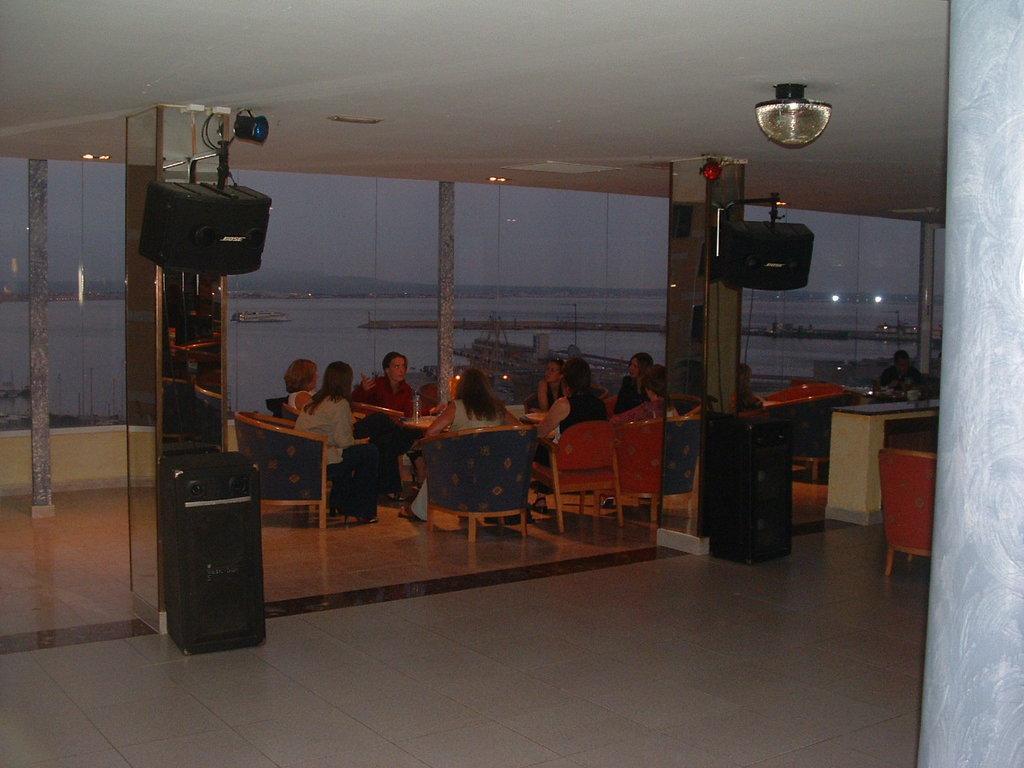Describe this image in one or two sentences. As we can see in the image there are water, few people sitting on chairs, tables and white color tiles over here. 